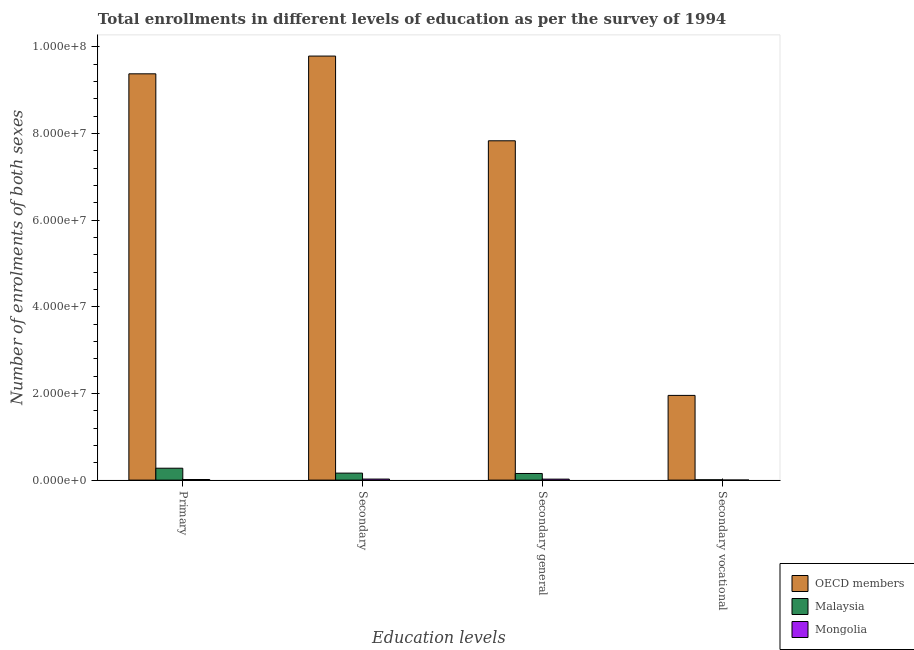How many different coloured bars are there?
Your answer should be very brief. 3. How many groups of bars are there?
Make the answer very short. 4. Are the number of bars per tick equal to the number of legend labels?
Offer a very short reply. Yes. Are the number of bars on each tick of the X-axis equal?
Offer a terse response. Yes. How many bars are there on the 3rd tick from the right?
Ensure brevity in your answer.  3. What is the label of the 1st group of bars from the left?
Give a very brief answer. Primary. What is the number of enrolments in secondary education in OECD members?
Your answer should be compact. 9.78e+07. Across all countries, what is the maximum number of enrolments in secondary vocational education?
Ensure brevity in your answer.  1.95e+07. Across all countries, what is the minimum number of enrolments in secondary education?
Keep it short and to the point. 2.40e+05. In which country was the number of enrolments in secondary education maximum?
Offer a very short reply. OECD members. In which country was the number of enrolments in secondary general education minimum?
Ensure brevity in your answer.  Mongolia. What is the total number of enrolments in secondary general education in the graph?
Ensure brevity in your answer.  8.00e+07. What is the difference between the number of enrolments in secondary vocational education in Mongolia and that in Malaysia?
Provide a succinct answer. -6.92e+04. What is the difference between the number of enrolments in secondary education in Mongolia and the number of enrolments in secondary general education in Malaysia?
Your response must be concise. -1.29e+06. What is the average number of enrolments in primary education per country?
Keep it short and to the point. 3.22e+07. What is the difference between the number of enrolments in primary education and number of enrolments in secondary general education in Malaysia?
Make the answer very short. 1.21e+06. In how many countries, is the number of enrolments in secondary vocational education greater than 28000000 ?
Provide a short and direct response. 0. What is the ratio of the number of enrolments in secondary education in Mongolia to that in OECD members?
Your answer should be very brief. 0. Is the number of enrolments in primary education in Mongolia less than that in OECD members?
Your answer should be compact. Yes. What is the difference between the highest and the second highest number of enrolments in secondary vocational education?
Give a very brief answer. 1.95e+07. What is the difference between the highest and the lowest number of enrolments in primary education?
Give a very brief answer. 9.36e+07. Is the sum of the number of enrolments in primary education in Mongolia and OECD members greater than the maximum number of enrolments in secondary education across all countries?
Make the answer very short. No. Is it the case that in every country, the sum of the number of enrolments in secondary vocational education and number of enrolments in secondary general education is greater than the sum of number of enrolments in primary education and number of enrolments in secondary education?
Your response must be concise. No. What does the 3rd bar from the left in Primary represents?
Offer a very short reply. Mongolia. What does the 3rd bar from the right in Secondary represents?
Your response must be concise. OECD members. How many countries are there in the graph?
Keep it short and to the point. 3. Does the graph contain grids?
Your response must be concise. No. Where does the legend appear in the graph?
Offer a terse response. Bottom right. How many legend labels are there?
Give a very brief answer. 3. What is the title of the graph?
Provide a succinct answer. Total enrollments in different levels of education as per the survey of 1994. What is the label or title of the X-axis?
Ensure brevity in your answer.  Education levels. What is the label or title of the Y-axis?
Provide a succinct answer. Number of enrolments of both sexes. What is the Number of enrolments of both sexes of OECD members in Primary?
Offer a terse response. 9.37e+07. What is the Number of enrolments of both sexes in Malaysia in Primary?
Offer a very short reply. 2.74e+06. What is the Number of enrolments of both sexes of Mongolia in Primary?
Keep it short and to the point. 1.42e+05. What is the Number of enrolments of both sexes in OECD members in Secondary?
Provide a short and direct response. 9.78e+07. What is the Number of enrolments of both sexes of Malaysia in Secondary?
Give a very brief answer. 1.61e+06. What is the Number of enrolments of both sexes of Mongolia in Secondary?
Your response must be concise. 2.40e+05. What is the Number of enrolments of both sexes in OECD members in Secondary general?
Give a very brief answer. 7.83e+07. What is the Number of enrolments of both sexes of Malaysia in Secondary general?
Your answer should be very brief. 1.53e+06. What is the Number of enrolments of both sexes of Mongolia in Secondary general?
Your response must be concise. 2.28e+05. What is the Number of enrolments of both sexes in OECD members in Secondary vocational?
Provide a succinct answer. 1.95e+07. What is the Number of enrolments of both sexes of Malaysia in Secondary vocational?
Ensure brevity in your answer.  8.07e+04. What is the Number of enrolments of both sexes in Mongolia in Secondary vocational?
Your answer should be very brief. 1.15e+04. Across all Education levels, what is the maximum Number of enrolments of both sexes in OECD members?
Offer a terse response. 9.78e+07. Across all Education levels, what is the maximum Number of enrolments of both sexes of Malaysia?
Offer a very short reply. 2.74e+06. Across all Education levels, what is the maximum Number of enrolments of both sexes in Mongolia?
Your answer should be compact. 2.40e+05. Across all Education levels, what is the minimum Number of enrolments of both sexes in OECD members?
Provide a short and direct response. 1.95e+07. Across all Education levels, what is the minimum Number of enrolments of both sexes in Malaysia?
Your answer should be compact. 8.07e+04. Across all Education levels, what is the minimum Number of enrolments of both sexes in Mongolia?
Keep it short and to the point. 1.15e+04. What is the total Number of enrolments of both sexes of OECD members in the graph?
Offer a very short reply. 2.89e+08. What is the total Number of enrolments of both sexes in Malaysia in the graph?
Make the answer very short. 5.97e+06. What is the total Number of enrolments of both sexes of Mongolia in the graph?
Your response must be concise. 6.21e+05. What is the difference between the Number of enrolments of both sexes in OECD members in Primary and that in Secondary?
Offer a terse response. -4.09e+06. What is the difference between the Number of enrolments of both sexes of Malaysia in Primary and that in Secondary?
Offer a very short reply. 1.13e+06. What is the difference between the Number of enrolments of both sexes in Mongolia in Primary and that in Secondary?
Make the answer very short. -9.75e+04. What is the difference between the Number of enrolments of both sexes of OECD members in Primary and that in Secondary general?
Make the answer very short. 1.54e+07. What is the difference between the Number of enrolments of both sexes in Malaysia in Primary and that in Secondary general?
Your response must be concise. 1.21e+06. What is the difference between the Number of enrolments of both sexes of Mongolia in Primary and that in Secondary general?
Give a very brief answer. -8.60e+04. What is the difference between the Number of enrolments of both sexes of OECD members in Primary and that in Secondary vocational?
Provide a succinct answer. 7.42e+07. What is the difference between the Number of enrolments of both sexes of Malaysia in Primary and that in Secondary vocational?
Provide a short and direct response. 2.66e+06. What is the difference between the Number of enrolments of both sexes in Mongolia in Primary and that in Secondary vocational?
Ensure brevity in your answer.  1.31e+05. What is the difference between the Number of enrolments of both sexes of OECD members in Secondary and that in Secondary general?
Your answer should be very brief. 1.95e+07. What is the difference between the Number of enrolments of both sexes in Malaysia in Secondary and that in Secondary general?
Provide a succinct answer. 8.07e+04. What is the difference between the Number of enrolments of both sexes of Mongolia in Secondary and that in Secondary general?
Make the answer very short. 1.15e+04. What is the difference between the Number of enrolments of both sexes of OECD members in Secondary and that in Secondary vocational?
Offer a terse response. 7.83e+07. What is the difference between the Number of enrolments of both sexes of Malaysia in Secondary and that in Secondary vocational?
Provide a succinct answer. 1.53e+06. What is the difference between the Number of enrolments of both sexes of Mongolia in Secondary and that in Secondary vocational?
Your response must be concise. 2.28e+05. What is the difference between the Number of enrolments of both sexes of OECD members in Secondary general and that in Secondary vocational?
Your answer should be very brief. 5.87e+07. What is the difference between the Number of enrolments of both sexes in Malaysia in Secondary general and that in Secondary vocational?
Offer a very short reply. 1.45e+06. What is the difference between the Number of enrolments of both sexes of Mongolia in Secondary general and that in Secondary vocational?
Make the answer very short. 2.17e+05. What is the difference between the Number of enrolments of both sexes of OECD members in Primary and the Number of enrolments of both sexes of Malaysia in Secondary?
Your response must be concise. 9.21e+07. What is the difference between the Number of enrolments of both sexes of OECD members in Primary and the Number of enrolments of both sexes of Mongolia in Secondary?
Provide a succinct answer. 9.35e+07. What is the difference between the Number of enrolments of both sexes of Malaysia in Primary and the Number of enrolments of both sexes of Mongolia in Secondary?
Your response must be concise. 2.51e+06. What is the difference between the Number of enrolments of both sexes of OECD members in Primary and the Number of enrolments of both sexes of Malaysia in Secondary general?
Provide a succinct answer. 9.22e+07. What is the difference between the Number of enrolments of both sexes of OECD members in Primary and the Number of enrolments of both sexes of Mongolia in Secondary general?
Your answer should be compact. 9.35e+07. What is the difference between the Number of enrolments of both sexes of Malaysia in Primary and the Number of enrolments of both sexes of Mongolia in Secondary general?
Offer a very short reply. 2.52e+06. What is the difference between the Number of enrolments of both sexes of OECD members in Primary and the Number of enrolments of both sexes of Malaysia in Secondary vocational?
Your answer should be very brief. 9.37e+07. What is the difference between the Number of enrolments of both sexes in OECD members in Primary and the Number of enrolments of both sexes in Mongolia in Secondary vocational?
Provide a short and direct response. 9.37e+07. What is the difference between the Number of enrolments of both sexes in Malaysia in Primary and the Number of enrolments of both sexes in Mongolia in Secondary vocational?
Offer a very short reply. 2.73e+06. What is the difference between the Number of enrolments of both sexes of OECD members in Secondary and the Number of enrolments of both sexes of Malaysia in Secondary general?
Your response must be concise. 9.63e+07. What is the difference between the Number of enrolments of both sexes in OECD members in Secondary and the Number of enrolments of both sexes in Mongolia in Secondary general?
Make the answer very short. 9.76e+07. What is the difference between the Number of enrolments of both sexes of Malaysia in Secondary and the Number of enrolments of both sexes of Mongolia in Secondary general?
Offer a terse response. 1.39e+06. What is the difference between the Number of enrolments of both sexes in OECD members in Secondary and the Number of enrolments of both sexes in Malaysia in Secondary vocational?
Offer a terse response. 9.77e+07. What is the difference between the Number of enrolments of both sexes of OECD members in Secondary and the Number of enrolments of both sexes of Mongolia in Secondary vocational?
Offer a very short reply. 9.78e+07. What is the difference between the Number of enrolments of both sexes in Malaysia in Secondary and the Number of enrolments of both sexes in Mongolia in Secondary vocational?
Provide a succinct answer. 1.60e+06. What is the difference between the Number of enrolments of both sexes in OECD members in Secondary general and the Number of enrolments of both sexes in Malaysia in Secondary vocational?
Give a very brief answer. 7.82e+07. What is the difference between the Number of enrolments of both sexes in OECD members in Secondary general and the Number of enrolments of both sexes in Mongolia in Secondary vocational?
Your answer should be very brief. 7.83e+07. What is the difference between the Number of enrolments of both sexes of Malaysia in Secondary general and the Number of enrolments of both sexes of Mongolia in Secondary vocational?
Ensure brevity in your answer.  1.52e+06. What is the average Number of enrolments of both sexes of OECD members per Education levels?
Make the answer very short. 7.23e+07. What is the average Number of enrolments of both sexes of Malaysia per Education levels?
Your response must be concise. 1.49e+06. What is the average Number of enrolments of both sexes of Mongolia per Education levels?
Ensure brevity in your answer.  1.55e+05. What is the difference between the Number of enrolments of both sexes in OECD members and Number of enrolments of both sexes in Malaysia in Primary?
Make the answer very short. 9.10e+07. What is the difference between the Number of enrolments of both sexes in OECD members and Number of enrolments of both sexes in Mongolia in Primary?
Offer a very short reply. 9.36e+07. What is the difference between the Number of enrolments of both sexes of Malaysia and Number of enrolments of both sexes of Mongolia in Primary?
Give a very brief answer. 2.60e+06. What is the difference between the Number of enrolments of both sexes in OECD members and Number of enrolments of both sexes in Malaysia in Secondary?
Offer a very short reply. 9.62e+07. What is the difference between the Number of enrolments of both sexes of OECD members and Number of enrolments of both sexes of Mongolia in Secondary?
Make the answer very short. 9.76e+07. What is the difference between the Number of enrolments of both sexes of Malaysia and Number of enrolments of both sexes of Mongolia in Secondary?
Give a very brief answer. 1.37e+06. What is the difference between the Number of enrolments of both sexes in OECD members and Number of enrolments of both sexes in Malaysia in Secondary general?
Make the answer very short. 7.68e+07. What is the difference between the Number of enrolments of both sexes of OECD members and Number of enrolments of both sexes of Mongolia in Secondary general?
Provide a succinct answer. 7.81e+07. What is the difference between the Number of enrolments of both sexes in Malaysia and Number of enrolments of both sexes in Mongolia in Secondary general?
Your answer should be very brief. 1.30e+06. What is the difference between the Number of enrolments of both sexes in OECD members and Number of enrolments of both sexes in Malaysia in Secondary vocational?
Give a very brief answer. 1.95e+07. What is the difference between the Number of enrolments of both sexes of OECD members and Number of enrolments of both sexes of Mongolia in Secondary vocational?
Your answer should be compact. 1.95e+07. What is the difference between the Number of enrolments of both sexes of Malaysia and Number of enrolments of both sexes of Mongolia in Secondary vocational?
Make the answer very short. 6.92e+04. What is the ratio of the Number of enrolments of both sexes in OECD members in Primary to that in Secondary?
Offer a terse response. 0.96. What is the ratio of the Number of enrolments of both sexes in Malaysia in Primary to that in Secondary?
Provide a short and direct response. 1.7. What is the ratio of the Number of enrolments of both sexes in Mongolia in Primary to that in Secondary?
Provide a succinct answer. 0.59. What is the ratio of the Number of enrolments of both sexes of OECD members in Primary to that in Secondary general?
Provide a succinct answer. 1.2. What is the ratio of the Number of enrolments of both sexes in Malaysia in Primary to that in Secondary general?
Offer a terse response. 1.79. What is the ratio of the Number of enrolments of both sexes of Mongolia in Primary to that in Secondary general?
Provide a short and direct response. 0.62. What is the ratio of the Number of enrolments of both sexes in OECD members in Primary to that in Secondary vocational?
Keep it short and to the point. 4.8. What is the ratio of the Number of enrolments of both sexes in Malaysia in Primary to that in Secondary vocational?
Ensure brevity in your answer.  34.02. What is the ratio of the Number of enrolments of both sexes of Mongolia in Primary to that in Secondary vocational?
Provide a succinct answer. 12.37. What is the ratio of the Number of enrolments of both sexes of OECD members in Secondary to that in Secondary general?
Your response must be concise. 1.25. What is the ratio of the Number of enrolments of both sexes of Malaysia in Secondary to that in Secondary general?
Your answer should be very brief. 1.05. What is the ratio of the Number of enrolments of both sexes in Mongolia in Secondary to that in Secondary general?
Your response must be concise. 1.05. What is the ratio of the Number of enrolments of both sexes in OECD members in Secondary to that in Secondary vocational?
Provide a succinct answer. 5.01. What is the ratio of the Number of enrolments of both sexes of Malaysia in Secondary to that in Secondary vocational?
Offer a very short reply. 19.99. What is the ratio of the Number of enrolments of both sexes of Mongolia in Secondary to that in Secondary vocational?
Offer a terse response. 20.86. What is the ratio of the Number of enrolments of both sexes of OECD members in Secondary general to that in Secondary vocational?
Keep it short and to the point. 4.01. What is the ratio of the Number of enrolments of both sexes of Malaysia in Secondary general to that in Secondary vocational?
Your response must be concise. 18.99. What is the ratio of the Number of enrolments of both sexes of Mongolia in Secondary general to that in Secondary vocational?
Keep it short and to the point. 19.86. What is the difference between the highest and the second highest Number of enrolments of both sexes of OECD members?
Your response must be concise. 4.09e+06. What is the difference between the highest and the second highest Number of enrolments of both sexes in Malaysia?
Ensure brevity in your answer.  1.13e+06. What is the difference between the highest and the second highest Number of enrolments of both sexes in Mongolia?
Keep it short and to the point. 1.15e+04. What is the difference between the highest and the lowest Number of enrolments of both sexes of OECD members?
Provide a succinct answer. 7.83e+07. What is the difference between the highest and the lowest Number of enrolments of both sexes in Malaysia?
Your answer should be very brief. 2.66e+06. What is the difference between the highest and the lowest Number of enrolments of both sexes of Mongolia?
Keep it short and to the point. 2.28e+05. 